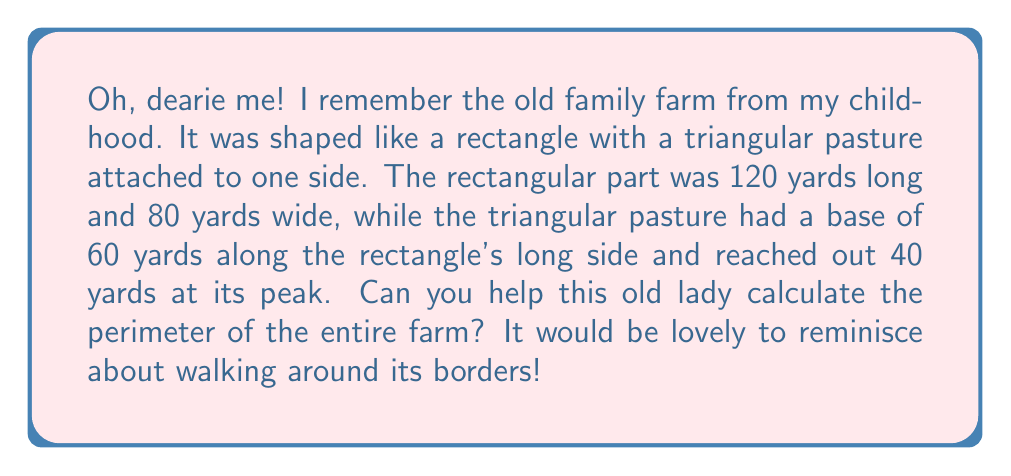Teach me how to tackle this problem. Certainly! Let's break this down step-by-step, just like we used to count our chickens back in the day.

1) First, let's visualize the farm:

[asy]
unitsize(2mm);
path rectangle = (0,0)--(120,0)--(120,80)--(0,80)--cycle;
path triangle = (120,0)--(180,0)--(120,40)--cycle;
draw(rectangle);
draw(triangle);
label("120 yards", (60,-5));
label("80 yards", (-5,40));
label("60 yards", (150,-5));
label("40 yards", (125,20), E);
[/asy]

2) Now, let's calculate the perimeter. We need to add up all the sides of the shape.

3) The rectangular part contributes:
   $$ 2 \times (120 \text{ yards} + 80 \text{ yards}) = 400 \text{ yards} $$

4) But we don't include the full 120 yards on the right side, as the triangle is attached there. We subtract the 60 yards where the triangle connects:
   $$ 400 \text{ yards} - 60 \text{ yards} = 340 \text{ yards} $$

5) Now for the triangular part. We need to add the two exposed sides. We know the base is 60 yards, but we need to calculate the slanted side using the Pythagorean theorem:
   $$ a^2 + 40^2 = 60^2 $$
   $$ a^2 + 1600 = 3600 $$
   $$ a^2 = 2000 $$
   $$ a = \sqrt{2000} \approx 44.72 \text{ yards} $$

6) Adding these to our perimeter:
   $$ 340 \text{ yards} + 60 \text{ yards} + 44.72 \text{ yards} = 444.72 \text{ yards} $$

7) Rounding to the nearest yard (we didn't measure that precisely in my day!):
   $$ 445 \text{ yards} $$
Answer: The perimeter of the old family farm is approximately 445 yards. 